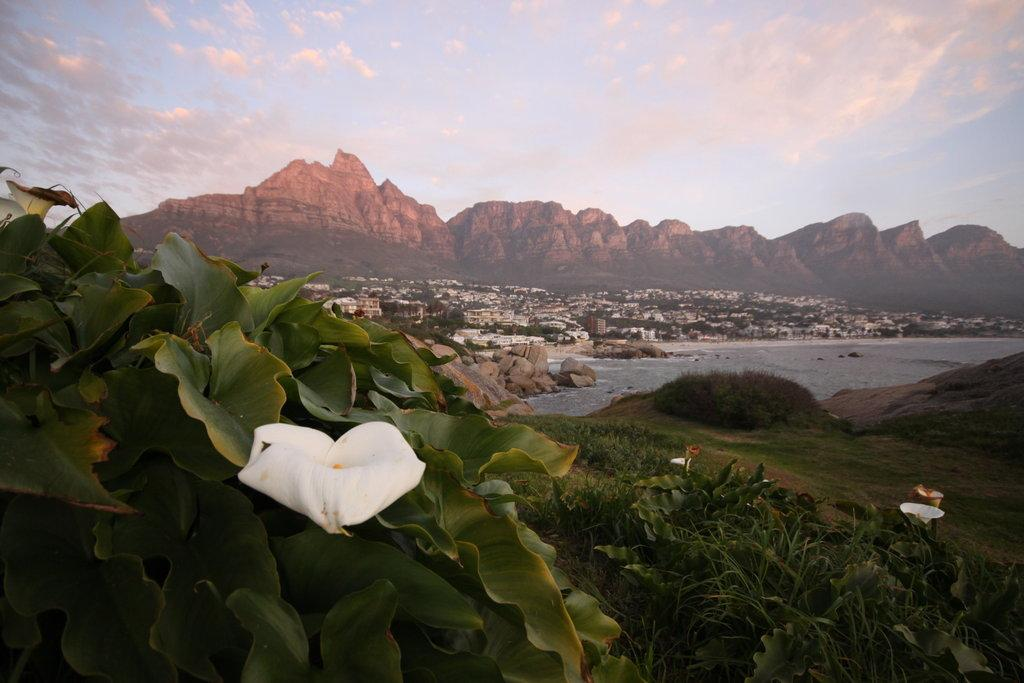What is the weather like in the image? The sky is cloudy in the image. What can be seen in the background of the image? There are mountains and buildings in the distance. What type of vegetation is present in the image? There are plants with flowers in the image. What type of ground cover is visible in the image? There is grass visible in the image. What body of water can be seen in the image? There is water visible in the image. What type of skirt is being worn by the record in the image? There is no record or skirt present in the image. 